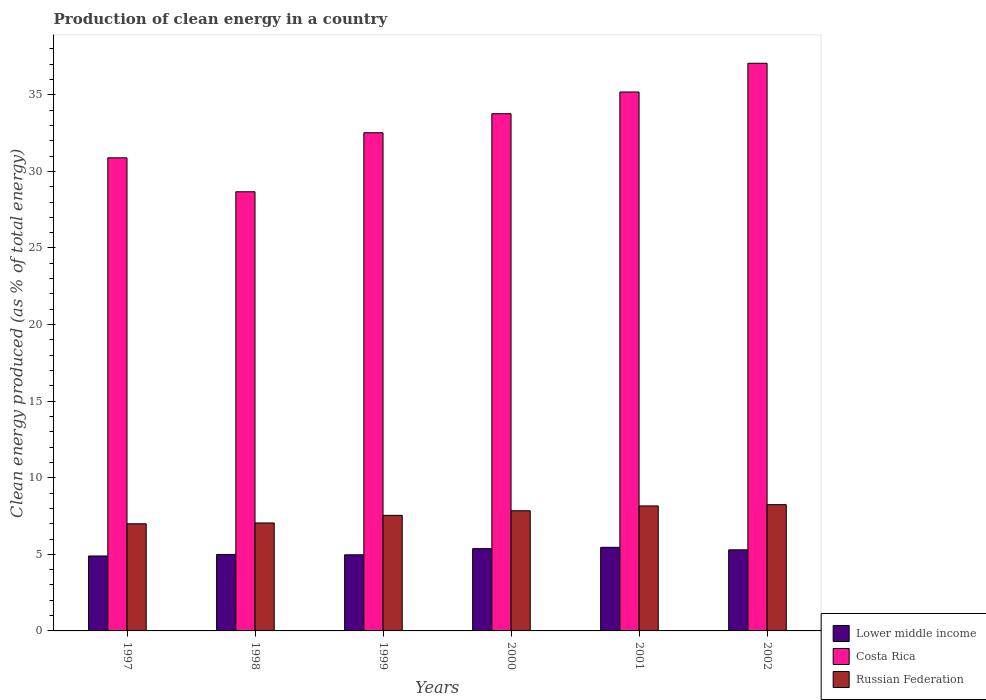How many different coloured bars are there?
Keep it short and to the point. 3. Are the number of bars on each tick of the X-axis equal?
Your response must be concise. Yes. How many bars are there on the 4th tick from the left?
Provide a succinct answer. 3. How many bars are there on the 1st tick from the right?
Make the answer very short. 3. In how many cases, is the number of bars for a given year not equal to the number of legend labels?
Provide a short and direct response. 0. What is the percentage of clean energy produced in Costa Rica in 1998?
Your answer should be compact. 28.67. Across all years, what is the maximum percentage of clean energy produced in Costa Rica?
Keep it short and to the point. 37.06. Across all years, what is the minimum percentage of clean energy produced in Lower middle income?
Your response must be concise. 4.89. In which year was the percentage of clean energy produced in Russian Federation maximum?
Provide a short and direct response. 2002. What is the total percentage of clean energy produced in Russian Federation in the graph?
Your answer should be very brief. 45.83. What is the difference between the percentage of clean energy produced in Costa Rica in 1998 and that in 2002?
Make the answer very short. -8.39. What is the difference between the percentage of clean energy produced in Lower middle income in 2000 and the percentage of clean energy produced in Costa Rica in 1998?
Ensure brevity in your answer.  -23.3. What is the average percentage of clean energy produced in Lower middle income per year?
Your response must be concise. 5.16. In the year 2000, what is the difference between the percentage of clean energy produced in Lower middle income and percentage of clean energy produced in Costa Rica?
Your response must be concise. -28.39. What is the ratio of the percentage of clean energy produced in Costa Rica in 1998 to that in 1999?
Keep it short and to the point. 0.88. Is the percentage of clean energy produced in Costa Rica in 1997 less than that in 2000?
Give a very brief answer. Yes. What is the difference between the highest and the second highest percentage of clean energy produced in Russian Federation?
Ensure brevity in your answer.  0.08. What is the difference between the highest and the lowest percentage of clean energy produced in Costa Rica?
Your answer should be very brief. 8.39. In how many years, is the percentage of clean energy produced in Russian Federation greater than the average percentage of clean energy produced in Russian Federation taken over all years?
Ensure brevity in your answer.  3. Is the sum of the percentage of clean energy produced in Costa Rica in 1999 and 2000 greater than the maximum percentage of clean energy produced in Lower middle income across all years?
Provide a succinct answer. Yes. What does the 2nd bar from the left in 2001 represents?
Provide a short and direct response. Costa Rica. What does the 3rd bar from the right in 2000 represents?
Offer a very short reply. Lower middle income. Is it the case that in every year, the sum of the percentage of clean energy produced in Lower middle income and percentage of clean energy produced in Russian Federation is greater than the percentage of clean energy produced in Costa Rica?
Your answer should be compact. No. How many bars are there?
Your answer should be very brief. 18. Are all the bars in the graph horizontal?
Make the answer very short. No. How many years are there in the graph?
Your answer should be compact. 6. What is the difference between two consecutive major ticks on the Y-axis?
Offer a terse response. 5. Does the graph contain any zero values?
Provide a succinct answer. No. Where does the legend appear in the graph?
Give a very brief answer. Bottom right. What is the title of the graph?
Your response must be concise. Production of clean energy in a country. Does "Benin" appear as one of the legend labels in the graph?
Your response must be concise. No. What is the label or title of the Y-axis?
Offer a very short reply. Clean energy produced (as % of total energy). What is the Clean energy produced (as % of total energy) of Lower middle income in 1997?
Ensure brevity in your answer.  4.89. What is the Clean energy produced (as % of total energy) of Costa Rica in 1997?
Provide a short and direct response. 30.89. What is the Clean energy produced (as % of total energy) in Russian Federation in 1997?
Your answer should be compact. 6.99. What is the Clean energy produced (as % of total energy) of Lower middle income in 1998?
Your answer should be very brief. 4.99. What is the Clean energy produced (as % of total energy) of Costa Rica in 1998?
Offer a terse response. 28.67. What is the Clean energy produced (as % of total energy) in Russian Federation in 1998?
Your answer should be compact. 7.05. What is the Clean energy produced (as % of total energy) in Lower middle income in 1999?
Your answer should be very brief. 4.97. What is the Clean energy produced (as % of total energy) in Costa Rica in 1999?
Keep it short and to the point. 32.52. What is the Clean energy produced (as % of total energy) of Russian Federation in 1999?
Give a very brief answer. 7.54. What is the Clean energy produced (as % of total energy) of Lower middle income in 2000?
Provide a short and direct response. 5.37. What is the Clean energy produced (as % of total energy) in Costa Rica in 2000?
Ensure brevity in your answer.  33.76. What is the Clean energy produced (as % of total energy) in Russian Federation in 2000?
Your response must be concise. 7.84. What is the Clean energy produced (as % of total energy) of Lower middle income in 2001?
Make the answer very short. 5.46. What is the Clean energy produced (as % of total energy) in Costa Rica in 2001?
Keep it short and to the point. 35.18. What is the Clean energy produced (as % of total energy) of Russian Federation in 2001?
Provide a short and direct response. 8.16. What is the Clean energy produced (as % of total energy) of Lower middle income in 2002?
Provide a succinct answer. 5.29. What is the Clean energy produced (as % of total energy) in Costa Rica in 2002?
Your answer should be compact. 37.06. What is the Clean energy produced (as % of total energy) of Russian Federation in 2002?
Your response must be concise. 8.24. Across all years, what is the maximum Clean energy produced (as % of total energy) of Lower middle income?
Provide a short and direct response. 5.46. Across all years, what is the maximum Clean energy produced (as % of total energy) of Costa Rica?
Make the answer very short. 37.06. Across all years, what is the maximum Clean energy produced (as % of total energy) of Russian Federation?
Keep it short and to the point. 8.24. Across all years, what is the minimum Clean energy produced (as % of total energy) in Lower middle income?
Make the answer very short. 4.89. Across all years, what is the minimum Clean energy produced (as % of total energy) of Costa Rica?
Make the answer very short. 28.67. Across all years, what is the minimum Clean energy produced (as % of total energy) in Russian Federation?
Provide a short and direct response. 6.99. What is the total Clean energy produced (as % of total energy) in Lower middle income in the graph?
Your response must be concise. 30.98. What is the total Clean energy produced (as % of total energy) in Costa Rica in the graph?
Ensure brevity in your answer.  198.09. What is the total Clean energy produced (as % of total energy) of Russian Federation in the graph?
Make the answer very short. 45.83. What is the difference between the Clean energy produced (as % of total energy) of Lower middle income in 1997 and that in 1998?
Your answer should be compact. -0.1. What is the difference between the Clean energy produced (as % of total energy) of Costa Rica in 1997 and that in 1998?
Offer a very short reply. 2.22. What is the difference between the Clean energy produced (as % of total energy) in Russian Federation in 1997 and that in 1998?
Your response must be concise. -0.05. What is the difference between the Clean energy produced (as % of total energy) of Lower middle income in 1997 and that in 1999?
Offer a terse response. -0.08. What is the difference between the Clean energy produced (as % of total energy) in Costa Rica in 1997 and that in 1999?
Ensure brevity in your answer.  -1.64. What is the difference between the Clean energy produced (as % of total energy) in Russian Federation in 1997 and that in 1999?
Your answer should be very brief. -0.55. What is the difference between the Clean energy produced (as % of total energy) in Lower middle income in 1997 and that in 2000?
Offer a very short reply. -0.48. What is the difference between the Clean energy produced (as % of total energy) in Costa Rica in 1997 and that in 2000?
Keep it short and to the point. -2.88. What is the difference between the Clean energy produced (as % of total energy) in Russian Federation in 1997 and that in 2000?
Provide a short and direct response. -0.85. What is the difference between the Clean energy produced (as % of total energy) of Lower middle income in 1997 and that in 2001?
Provide a succinct answer. -0.56. What is the difference between the Clean energy produced (as % of total energy) of Costa Rica in 1997 and that in 2001?
Provide a succinct answer. -4.3. What is the difference between the Clean energy produced (as % of total energy) in Russian Federation in 1997 and that in 2001?
Ensure brevity in your answer.  -1.17. What is the difference between the Clean energy produced (as % of total energy) of Lower middle income in 1997 and that in 2002?
Give a very brief answer. -0.4. What is the difference between the Clean energy produced (as % of total energy) of Costa Rica in 1997 and that in 2002?
Your answer should be compact. -6.17. What is the difference between the Clean energy produced (as % of total energy) of Russian Federation in 1997 and that in 2002?
Your answer should be compact. -1.25. What is the difference between the Clean energy produced (as % of total energy) in Lower middle income in 1998 and that in 1999?
Your response must be concise. 0.02. What is the difference between the Clean energy produced (as % of total energy) in Costa Rica in 1998 and that in 1999?
Offer a very short reply. -3.85. What is the difference between the Clean energy produced (as % of total energy) in Russian Federation in 1998 and that in 1999?
Provide a succinct answer. -0.5. What is the difference between the Clean energy produced (as % of total energy) of Lower middle income in 1998 and that in 2000?
Your response must be concise. -0.38. What is the difference between the Clean energy produced (as % of total energy) of Costa Rica in 1998 and that in 2000?
Your answer should be very brief. -5.1. What is the difference between the Clean energy produced (as % of total energy) in Russian Federation in 1998 and that in 2000?
Provide a short and direct response. -0.8. What is the difference between the Clean energy produced (as % of total energy) in Lower middle income in 1998 and that in 2001?
Your answer should be very brief. -0.47. What is the difference between the Clean energy produced (as % of total energy) in Costa Rica in 1998 and that in 2001?
Offer a terse response. -6.52. What is the difference between the Clean energy produced (as % of total energy) of Russian Federation in 1998 and that in 2001?
Your answer should be compact. -1.11. What is the difference between the Clean energy produced (as % of total energy) in Lower middle income in 1998 and that in 2002?
Keep it short and to the point. -0.3. What is the difference between the Clean energy produced (as % of total energy) of Costa Rica in 1998 and that in 2002?
Your answer should be compact. -8.39. What is the difference between the Clean energy produced (as % of total energy) in Russian Federation in 1998 and that in 2002?
Ensure brevity in your answer.  -1.19. What is the difference between the Clean energy produced (as % of total energy) of Lower middle income in 1999 and that in 2000?
Your answer should be compact. -0.4. What is the difference between the Clean energy produced (as % of total energy) in Costa Rica in 1999 and that in 2000?
Make the answer very short. -1.24. What is the difference between the Clean energy produced (as % of total energy) in Russian Federation in 1999 and that in 2000?
Offer a terse response. -0.3. What is the difference between the Clean energy produced (as % of total energy) of Lower middle income in 1999 and that in 2001?
Your answer should be compact. -0.49. What is the difference between the Clean energy produced (as % of total energy) in Costa Rica in 1999 and that in 2001?
Make the answer very short. -2.66. What is the difference between the Clean energy produced (as % of total energy) in Russian Federation in 1999 and that in 2001?
Your response must be concise. -0.62. What is the difference between the Clean energy produced (as % of total energy) of Lower middle income in 1999 and that in 2002?
Offer a terse response. -0.32. What is the difference between the Clean energy produced (as % of total energy) in Costa Rica in 1999 and that in 2002?
Your answer should be compact. -4.54. What is the difference between the Clean energy produced (as % of total energy) of Russian Federation in 1999 and that in 2002?
Give a very brief answer. -0.7. What is the difference between the Clean energy produced (as % of total energy) of Lower middle income in 2000 and that in 2001?
Offer a terse response. -0.09. What is the difference between the Clean energy produced (as % of total energy) of Costa Rica in 2000 and that in 2001?
Your answer should be compact. -1.42. What is the difference between the Clean energy produced (as % of total energy) of Russian Federation in 2000 and that in 2001?
Your answer should be very brief. -0.32. What is the difference between the Clean energy produced (as % of total energy) of Lower middle income in 2000 and that in 2002?
Offer a terse response. 0.08. What is the difference between the Clean energy produced (as % of total energy) of Costa Rica in 2000 and that in 2002?
Your answer should be very brief. -3.3. What is the difference between the Clean energy produced (as % of total energy) in Russian Federation in 2000 and that in 2002?
Provide a succinct answer. -0.4. What is the difference between the Clean energy produced (as % of total energy) in Lower middle income in 2001 and that in 2002?
Provide a succinct answer. 0.16. What is the difference between the Clean energy produced (as % of total energy) of Costa Rica in 2001 and that in 2002?
Ensure brevity in your answer.  -1.88. What is the difference between the Clean energy produced (as % of total energy) of Russian Federation in 2001 and that in 2002?
Offer a very short reply. -0.08. What is the difference between the Clean energy produced (as % of total energy) of Lower middle income in 1997 and the Clean energy produced (as % of total energy) of Costa Rica in 1998?
Keep it short and to the point. -23.78. What is the difference between the Clean energy produced (as % of total energy) of Lower middle income in 1997 and the Clean energy produced (as % of total energy) of Russian Federation in 1998?
Ensure brevity in your answer.  -2.16. What is the difference between the Clean energy produced (as % of total energy) of Costa Rica in 1997 and the Clean energy produced (as % of total energy) of Russian Federation in 1998?
Ensure brevity in your answer.  23.84. What is the difference between the Clean energy produced (as % of total energy) of Lower middle income in 1997 and the Clean energy produced (as % of total energy) of Costa Rica in 1999?
Keep it short and to the point. -27.63. What is the difference between the Clean energy produced (as % of total energy) of Lower middle income in 1997 and the Clean energy produced (as % of total energy) of Russian Federation in 1999?
Ensure brevity in your answer.  -2.65. What is the difference between the Clean energy produced (as % of total energy) of Costa Rica in 1997 and the Clean energy produced (as % of total energy) of Russian Federation in 1999?
Your response must be concise. 23.34. What is the difference between the Clean energy produced (as % of total energy) of Lower middle income in 1997 and the Clean energy produced (as % of total energy) of Costa Rica in 2000?
Keep it short and to the point. -28.87. What is the difference between the Clean energy produced (as % of total energy) in Lower middle income in 1997 and the Clean energy produced (as % of total energy) in Russian Federation in 2000?
Provide a short and direct response. -2.95. What is the difference between the Clean energy produced (as % of total energy) of Costa Rica in 1997 and the Clean energy produced (as % of total energy) of Russian Federation in 2000?
Offer a terse response. 23.04. What is the difference between the Clean energy produced (as % of total energy) in Lower middle income in 1997 and the Clean energy produced (as % of total energy) in Costa Rica in 2001?
Your answer should be very brief. -30.29. What is the difference between the Clean energy produced (as % of total energy) in Lower middle income in 1997 and the Clean energy produced (as % of total energy) in Russian Federation in 2001?
Provide a succinct answer. -3.27. What is the difference between the Clean energy produced (as % of total energy) in Costa Rica in 1997 and the Clean energy produced (as % of total energy) in Russian Federation in 2001?
Offer a very short reply. 22.73. What is the difference between the Clean energy produced (as % of total energy) in Lower middle income in 1997 and the Clean energy produced (as % of total energy) in Costa Rica in 2002?
Offer a terse response. -32.17. What is the difference between the Clean energy produced (as % of total energy) in Lower middle income in 1997 and the Clean energy produced (as % of total energy) in Russian Federation in 2002?
Keep it short and to the point. -3.35. What is the difference between the Clean energy produced (as % of total energy) of Costa Rica in 1997 and the Clean energy produced (as % of total energy) of Russian Federation in 2002?
Your answer should be very brief. 22.64. What is the difference between the Clean energy produced (as % of total energy) in Lower middle income in 1998 and the Clean energy produced (as % of total energy) in Costa Rica in 1999?
Your answer should be compact. -27.53. What is the difference between the Clean energy produced (as % of total energy) of Lower middle income in 1998 and the Clean energy produced (as % of total energy) of Russian Federation in 1999?
Offer a very short reply. -2.55. What is the difference between the Clean energy produced (as % of total energy) in Costa Rica in 1998 and the Clean energy produced (as % of total energy) in Russian Federation in 1999?
Offer a very short reply. 21.12. What is the difference between the Clean energy produced (as % of total energy) in Lower middle income in 1998 and the Clean energy produced (as % of total energy) in Costa Rica in 2000?
Make the answer very short. -28.77. What is the difference between the Clean energy produced (as % of total energy) in Lower middle income in 1998 and the Clean energy produced (as % of total energy) in Russian Federation in 2000?
Your answer should be very brief. -2.85. What is the difference between the Clean energy produced (as % of total energy) of Costa Rica in 1998 and the Clean energy produced (as % of total energy) of Russian Federation in 2000?
Your response must be concise. 20.82. What is the difference between the Clean energy produced (as % of total energy) of Lower middle income in 1998 and the Clean energy produced (as % of total energy) of Costa Rica in 2001?
Give a very brief answer. -30.19. What is the difference between the Clean energy produced (as % of total energy) in Lower middle income in 1998 and the Clean energy produced (as % of total energy) in Russian Federation in 2001?
Give a very brief answer. -3.17. What is the difference between the Clean energy produced (as % of total energy) in Costa Rica in 1998 and the Clean energy produced (as % of total energy) in Russian Federation in 2001?
Ensure brevity in your answer.  20.51. What is the difference between the Clean energy produced (as % of total energy) of Lower middle income in 1998 and the Clean energy produced (as % of total energy) of Costa Rica in 2002?
Your response must be concise. -32.07. What is the difference between the Clean energy produced (as % of total energy) of Lower middle income in 1998 and the Clean energy produced (as % of total energy) of Russian Federation in 2002?
Provide a short and direct response. -3.25. What is the difference between the Clean energy produced (as % of total energy) of Costa Rica in 1998 and the Clean energy produced (as % of total energy) of Russian Federation in 2002?
Provide a short and direct response. 20.43. What is the difference between the Clean energy produced (as % of total energy) of Lower middle income in 1999 and the Clean energy produced (as % of total energy) of Costa Rica in 2000?
Provide a short and direct response. -28.8. What is the difference between the Clean energy produced (as % of total energy) in Lower middle income in 1999 and the Clean energy produced (as % of total energy) in Russian Federation in 2000?
Keep it short and to the point. -2.88. What is the difference between the Clean energy produced (as % of total energy) in Costa Rica in 1999 and the Clean energy produced (as % of total energy) in Russian Federation in 2000?
Make the answer very short. 24.68. What is the difference between the Clean energy produced (as % of total energy) of Lower middle income in 1999 and the Clean energy produced (as % of total energy) of Costa Rica in 2001?
Make the answer very short. -30.22. What is the difference between the Clean energy produced (as % of total energy) of Lower middle income in 1999 and the Clean energy produced (as % of total energy) of Russian Federation in 2001?
Give a very brief answer. -3.19. What is the difference between the Clean energy produced (as % of total energy) of Costa Rica in 1999 and the Clean energy produced (as % of total energy) of Russian Federation in 2001?
Your response must be concise. 24.36. What is the difference between the Clean energy produced (as % of total energy) in Lower middle income in 1999 and the Clean energy produced (as % of total energy) in Costa Rica in 2002?
Offer a very short reply. -32.09. What is the difference between the Clean energy produced (as % of total energy) in Lower middle income in 1999 and the Clean energy produced (as % of total energy) in Russian Federation in 2002?
Provide a short and direct response. -3.27. What is the difference between the Clean energy produced (as % of total energy) in Costa Rica in 1999 and the Clean energy produced (as % of total energy) in Russian Federation in 2002?
Your answer should be compact. 24.28. What is the difference between the Clean energy produced (as % of total energy) of Lower middle income in 2000 and the Clean energy produced (as % of total energy) of Costa Rica in 2001?
Your response must be concise. -29.81. What is the difference between the Clean energy produced (as % of total energy) in Lower middle income in 2000 and the Clean energy produced (as % of total energy) in Russian Federation in 2001?
Your response must be concise. -2.79. What is the difference between the Clean energy produced (as % of total energy) of Costa Rica in 2000 and the Clean energy produced (as % of total energy) of Russian Federation in 2001?
Your answer should be compact. 25.6. What is the difference between the Clean energy produced (as % of total energy) of Lower middle income in 2000 and the Clean energy produced (as % of total energy) of Costa Rica in 2002?
Provide a short and direct response. -31.69. What is the difference between the Clean energy produced (as % of total energy) of Lower middle income in 2000 and the Clean energy produced (as % of total energy) of Russian Federation in 2002?
Provide a short and direct response. -2.87. What is the difference between the Clean energy produced (as % of total energy) in Costa Rica in 2000 and the Clean energy produced (as % of total energy) in Russian Federation in 2002?
Your response must be concise. 25.52. What is the difference between the Clean energy produced (as % of total energy) of Lower middle income in 2001 and the Clean energy produced (as % of total energy) of Costa Rica in 2002?
Give a very brief answer. -31.6. What is the difference between the Clean energy produced (as % of total energy) in Lower middle income in 2001 and the Clean energy produced (as % of total energy) in Russian Federation in 2002?
Keep it short and to the point. -2.79. What is the difference between the Clean energy produced (as % of total energy) in Costa Rica in 2001 and the Clean energy produced (as % of total energy) in Russian Federation in 2002?
Keep it short and to the point. 26.94. What is the average Clean energy produced (as % of total energy) of Lower middle income per year?
Ensure brevity in your answer.  5.16. What is the average Clean energy produced (as % of total energy) in Costa Rica per year?
Offer a very short reply. 33.01. What is the average Clean energy produced (as % of total energy) in Russian Federation per year?
Make the answer very short. 7.64. In the year 1997, what is the difference between the Clean energy produced (as % of total energy) of Lower middle income and Clean energy produced (as % of total energy) of Costa Rica?
Ensure brevity in your answer.  -25.99. In the year 1997, what is the difference between the Clean energy produced (as % of total energy) in Lower middle income and Clean energy produced (as % of total energy) in Russian Federation?
Give a very brief answer. -2.1. In the year 1997, what is the difference between the Clean energy produced (as % of total energy) in Costa Rica and Clean energy produced (as % of total energy) in Russian Federation?
Your response must be concise. 23.89. In the year 1998, what is the difference between the Clean energy produced (as % of total energy) of Lower middle income and Clean energy produced (as % of total energy) of Costa Rica?
Keep it short and to the point. -23.68. In the year 1998, what is the difference between the Clean energy produced (as % of total energy) of Lower middle income and Clean energy produced (as % of total energy) of Russian Federation?
Make the answer very short. -2.06. In the year 1998, what is the difference between the Clean energy produced (as % of total energy) of Costa Rica and Clean energy produced (as % of total energy) of Russian Federation?
Provide a short and direct response. 21.62. In the year 1999, what is the difference between the Clean energy produced (as % of total energy) of Lower middle income and Clean energy produced (as % of total energy) of Costa Rica?
Offer a terse response. -27.55. In the year 1999, what is the difference between the Clean energy produced (as % of total energy) of Lower middle income and Clean energy produced (as % of total energy) of Russian Federation?
Your answer should be very brief. -2.58. In the year 1999, what is the difference between the Clean energy produced (as % of total energy) of Costa Rica and Clean energy produced (as % of total energy) of Russian Federation?
Your response must be concise. 24.98. In the year 2000, what is the difference between the Clean energy produced (as % of total energy) in Lower middle income and Clean energy produced (as % of total energy) in Costa Rica?
Provide a succinct answer. -28.39. In the year 2000, what is the difference between the Clean energy produced (as % of total energy) of Lower middle income and Clean energy produced (as % of total energy) of Russian Federation?
Make the answer very short. -2.47. In the year 2000, what is the difference between the Clean energy produced (as % of total energy) of Costa Rica and Clean energy produced (as % of total energy) of Russian Federation?
Provide a succinct answer. 25.92. In the year 2001, what is the difference between the Clean energy produced (as % of total energy) of Lower middle income and Clean energy produced (as % of total energy) of Costa Rica?
Keep it short and to the point. -29.73. In the year 2001, what is the difference between the Clean energy produced (as % of total energy) in Lower middle income and Clean energy produced (as % of total energy) in Russian Federation?
Give a very brief answer. -2.7. In the year 2001, what is the difference between the Clean energy produced (as % of total energy) in Costa Rica and Clean energy produced (as % of total energy) in Russian Federation?
Offer a very short reply. 27.02. In the year 2002, what is the difference between the Clean energy produced (as % of total energy) of Lower middle income and Clean energy produced (as % of total energy) of Costa Rica?
Offer a terse response. -31.77. In the year 2002, what is the difference between the Clean energy produced (as % of total energy) in Lower middle income and Clean energy produced (as % of total energy) in Russian Federation?
Give a very brief answer. -2.95. In the year 2002, what is the difference between the Clean energy produced (as % of total energy) of Costa Rica and Clean energy produced (as % of total energy) of Russian Federation?
Make the answer very short. 28.82. What is the ratio of the Clean energy produced (as % of total energy) in Lower middle income in 1997 to that in 1998?
Your response must be concise. 0.98. What is the ratio of the Clean energy produced (as % of total energy) of Costa Rica in 1997 to that in 1998?
Give a very brief answer. 1.08. What is the ratio of the Clean energy produced (as % of total energy) in Russian Federation in 1997 to that in 1998?
Provide a succinct answer. 0.99. What is the ratio of the Clean energy produced (as % of total energy) of Lower middle income in 1997 to that in 1999?
Offer a very short reply. 0.98. What is the ratio of the Clean energy produced (as % of total energy) in Costa Rica in 1997 to that in 1999?
Your response must be concise. 0.95. What is the ratio of the Clean energy produced (as % of total energy) of Russian Federation in 1997 to that in 1999?
Keep it short and to the point. 0.93. What is the ratio of the Clean energy produced (as % of total energy) in Lower middle income in 1997 to that in 2000?
Ensure brevity in your answer.  0.91. What is the ratio of the Clean energy produced (as % of total energy) of Costa Rica in 1997 to that in 2000?
Your answer should be compact. 0.91. What is the ratio of the Clean energy produced (as % of total energy) of Russian Federation in 1997 to that in 2000?
Your answer should be very brief. 0.89. What is the ratio of the Clean energy produced (as % of total energy) of Lower middle income in 1997 to that in 2001?
Provide a short and direct response. 0.9. What is the ratio of the Clean energy produced (as % of total energy) in Costa Rica in 1997 to that in 2001?
Your answer should be very brief. 0.88. What is the ratio of the Clean energy produced (as % of total energy) in Lower middle income in 1997 to that in 2002?
Ensure brevity in your answer.  0.92. What is the ratio of the Clean energy produced (as % of total energy) of Costa Rica in 1997 to that in 2002?
Make the answer very short. 0.83. What is the ratio of the Clean energy produced (as % of total energy) in Russian Federation in 1997 to that in 2002?
Keep it short and to the point. 0.85. What is the ratio of the Clean energy produced (as % of total energy) in Lower middle income in 1998 to that in 1999?
Provide a short and direct response. 1. What is the ratio of the Clean energy produced (as % of total energy) of Costa Rica in 1998 to that in 1999?
Offer a terse response. 0.88. What is the ratio of the Clean energy produced (as % of total energy) of Russian Federation in 1998 to that in 1999?
Provide a succinct answer. 0.93. What is the ratio of the Clean energy produced (as % of total energy) of Lower middle income in 1998 to that in 2000?
Ensure brevity in your answer.  0.93. What is the ratio of the Clean energy produced (as % of total energy) in Costa Rica in 1998 to that in 2000?
Your answer should be very brief. 0.85. What is the ratio of the Clean energy produced (as % of total energy) of Russian Federation in 1998 to that in 2000?
Provide a short and direct response. 0.9. What is the ratio of the Clean energy produced (as % of total energy) in Lower middle income in 1998 to that in 2001?
Give a very brief answer. 0.91. What is the ratio of the Clean energy produced (as % of total energy) of Costa Rica in 1998 to that in 2001?
Your response must be concise. 0.81. What is the ratio of the Clean energy produced (as % of total energy) in Russian Federation in 1998 to that in 2001?
Your response must be concise. 0.86. What is the ratio of the Clean energy produced (as % of total energy) in Lower middle income in 1998 to that in 2002?
Your response must be concise. 0.94. What is the ratio of the Clean energy produced (as % of total energy) in Costa Rica in 1998 to that in 2002?
Offer a terse response. 0.77. What is the ratio of the Clean energy produced (as % of total energy) in Russian Federation in 1998 to that in 2002?
Provide a short and direct response. 0.86. What is the ratio of the Clean energy produced (as % of total energy) of Lower middle income in 1999 to that in 2000?
Give a very brief answer. 0.93. What is the ratio of the Clean energy produced (as % of total energy) in Costa Rica in 1999 to that in 2000?
Ensure brevity in your answer.  0.96. What is the ratio of the Clean energy produced (as % of total energy) of Russian Federation in 1999 to that in 2000?
Your answer should be very brief. 0.96. What is the ratio of the Clean energy produced (as % of total energy) of Lower middle income in 1999 to that in 2001?
Keep it short and to the point. 0.91. What is the ratio of the Clean energy produced (as % of total energy) in Costa Rica in 1999 to that in 2001?
Keep it short and to the point. 0.92. What is the ratio of the Clean energy produced (as % of total energy) of Russian Federation in 1999 to that in 2001?
Ensure brevity in your answer.  0.92. What is the ratio of the Clean energy produced (as % of total energy) of Lower middle income in 1999 to that in 2002?
Offer a very short reply. 0.94. What is the ratio of the Clean energy produced (as % of total energy) in Costa Rica in 1999 to that in 2002?
Provide a succinct answer. 0.88. What is the ratio of the Clean energy produced (as % of total energy) in Russian Federation in 1999 to that in 2002?
Your answer should be compact. 0.92. What is the ratio of the Clean energy produced (as % of total energy) in Lower middle income in 2000 to that in 2001?
Keep it short and to the point. 0.98. What is the ratio of the Clean energy produced (as % of total energy) in Costa Rica in 2000 to that in 2001?
Give a very brief answer. 0.96. What is the ratio of the Clean energy produced (as % of total energy) of Russian Federation in 2000 to that in 2001?
Provide a short and direct response. 0.96. What is the ratio of the Clean energy produced (as % of total energy) in Lower middle income in 2000 to that in 2002?
Offer a terse response. 1.01. What is the ratio of the Clean energy produced (as % of total energy) in Costa Rica in 2000 to that in 2002?
Your answer should be very brief. 0.91. What is the ratio of the Clean energy produced (as % of total energy) of Russian Federation in 2000 to that in 2002?
Give a very brief answer. 0.95. What is the ratio of the Clean energy produced (as % of total energy) of Lower middle income in 2001 to that in 2002?
Provide a succinct answer. 1.03. What is the ratio of the Clean energy produced (as % of total energy) of Costa Rica in 2001 to that in 2002?
Your response must be concise. 0.95. What is the ratio of the Clean energy produced (as % of total energy) in Russian Federation in 2001 to that in 2002?
Give a very brief answer. 0.99. What is the difference between the highest and the second highest Clean energy produced (as % of total energy) in Lower middle income?
Your answer should be compact. 0.09. What is the difference between the highest and the second highest Clean energy produced (as % of total energy) of Costa Rica?
Make the answer very short. 1.88. What is the difference between the highest and the second highest Clean energy produced (as % of total energy) in Russian Federation?
Provide a succinct answer. 0.08. What is the difference between the highest and the lowest Clean energy produced (as % of total energy) of Lower middle income?
Provide a succinct answer. 0.56. What is the difference between the highest and the lowest Clean energy produced (as % of total energy) in Costa Rica?
Your response must be concise. 8.39. What is the difference between the highest and the lowest Clean energy produced (as % of total energy) of Russian Federation?
Offer a very short reply. 1.25. 